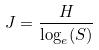<formula> <loc_0><loc_0><loc_500><loc_500>J = \frac { H } { \log _ { e } ( S ) }</formula> 